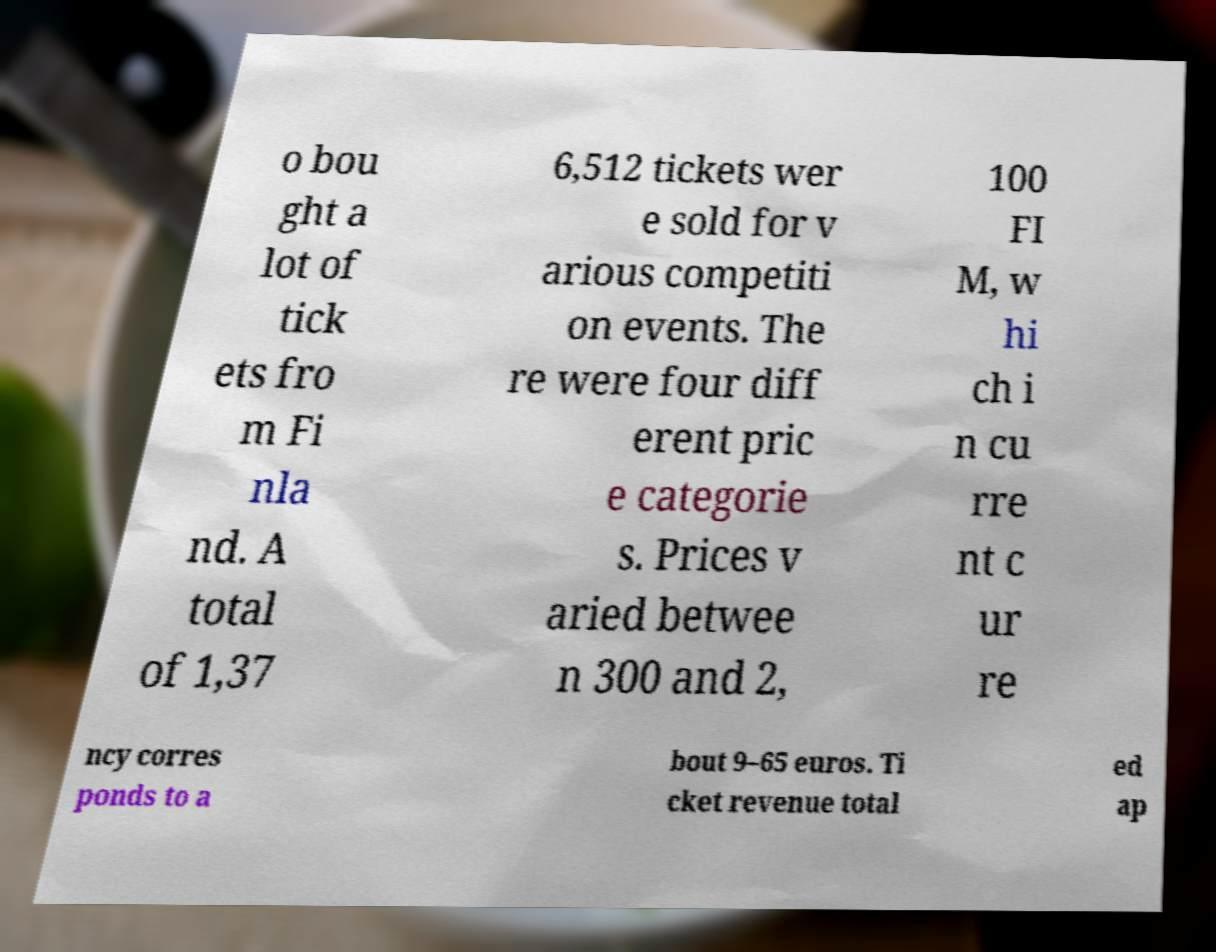Please identify and transcribe the text found in this image. o bou ght a lot of tick ets fro m Fi nla nd. A total of 1,37 6,512 tickets wer e sold for v arious competiti on events. The re were four diff erent pric e categorie s. Prices v aried betwee n 300 and 2, 100 FI M, w hi ch i n cu rre nt c ur re ncy corres ponds to a bout 9–65 euros. Ti cket revenue total ed ap 